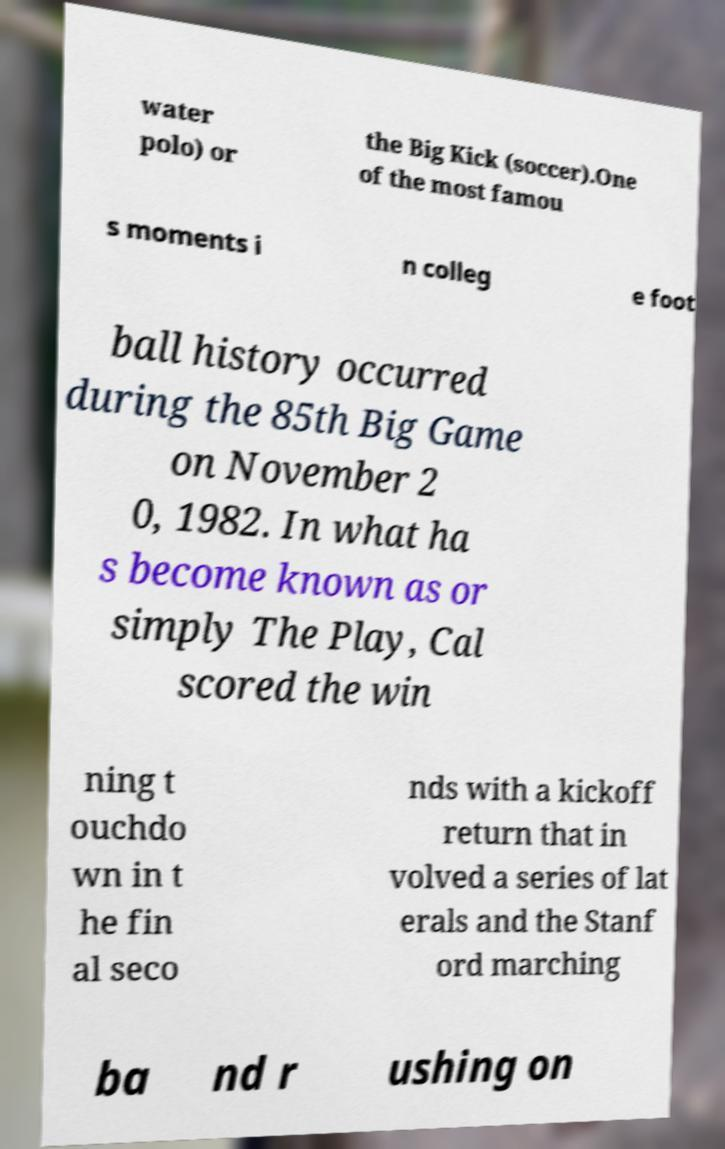Can you read and provide the text displayed in the image?This photo seems to have some interesting text. Can you extract and type it out for me? water polo) or the Big Kick (soccer).One of the most famou s moments i n colleg e foot ball history occurred during the 85th Big Game on November 2 0, 1982. In what ha s become known as or simply The Play, Cal scored the win ning t ouchdo wn in t he fin al seco nds with a kickoff return that in volved a series of lat erals and the Stanf ord marching ba nd r ushing on 